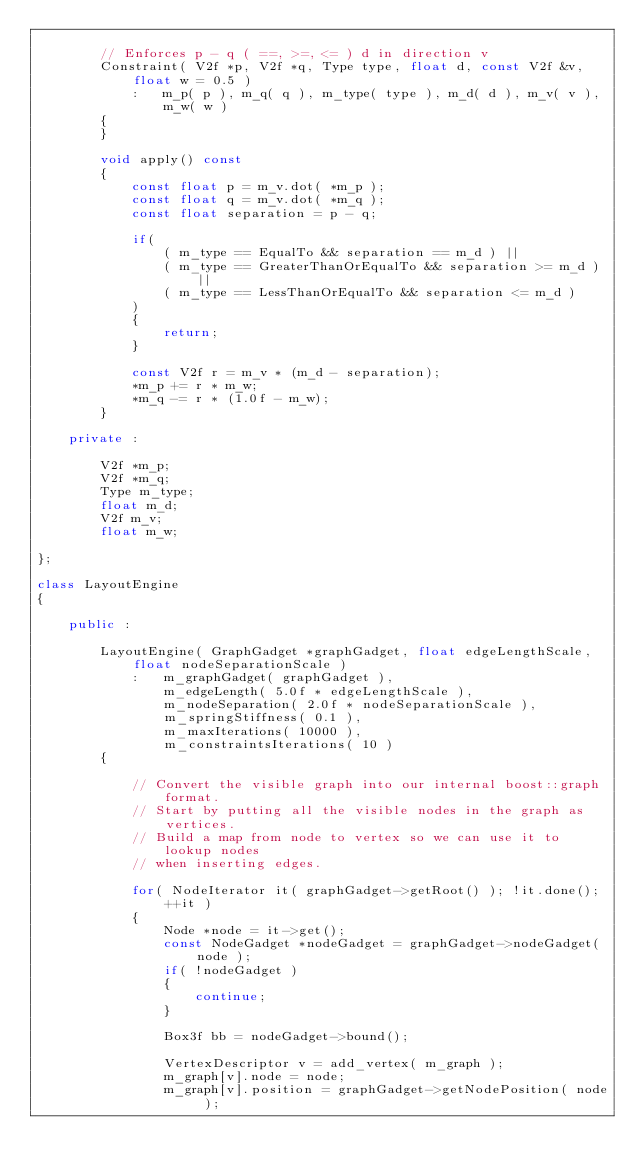<code> <loc_0><loc_0><loc_500><loc_500><_C++_>
		// Enforces p - q ( ==, >=, <= ) d in direction v
		Constraint( V2f *p, V2f *q, Type type, float d, const V2f &v, float w = 0.5 )
			:	m_p( p ), m_q( q ), m_type( type ), m_d( d ), m_v( v ), m_w( w )
		{
		}

		void apply() const
		{
			const float p = m_v.dot( *m_p );
			const float q = m_v.dot( *m_q );
			const float separation = p - q;

			if(
				( m_type == EqualTo && separation == m_d ) ||
				( m_type == GreaterThanOrEqualTo && separation >= m_d ) ||
				( m_type == LessThanOrEqualTo && separation <= m_d )
			)
			{
				return;
			}

			const V2f r = m_v * (m_d - separation);
			*m_p += r * m_w;
			*m_q -= r * (1.0f - m_w);
		}

	private :

		V2f *m_p;
		V2f *m_q;
		Type m_type;
		float m_d;
		V2f m_v;
		float m_w;

};

class LayoutEngine
{

	public :

		LayoutEngine( GraphGadget *graphGadget, float edgeLengthScale, float nodeSeparationScale )
			:	m_graphGadget( graphGadget ),
				m_edgeLength( 5.0f * edgeLengthScale ),
				m_nodeSeparation( 2.0f * nodeSeparationScale ),
				m_springStiffness( 0.1 ),
				m_maxIterations( 10000 ),
				m_constraintsIterations( 10 )
		{

			// Convert the visible graph into our internal boost::graph format.
			// Start by putting all the visible nodes in the graph as vertices.
			// Build a map from node to vertex so we can use it to lookup nodes
			// when inserting edges.

			for( NodeIterator it( graphGadget->getRoot() ); !it.done(); ++it )
			{
				Node *node = it->get();
				const NodeGadget *nodeGadget = graphGadget->nodeGadget( node );
				if( !nodeGadget )
				{
					continue;
				}

				Box3f bb = nodeGadget->bound();

				VertexDescriptor v = add_vertex( m_graph );
				m_graph[v].node = node;
				m_graph[v].position = graphGadget->getNodePosition( node );</code> 